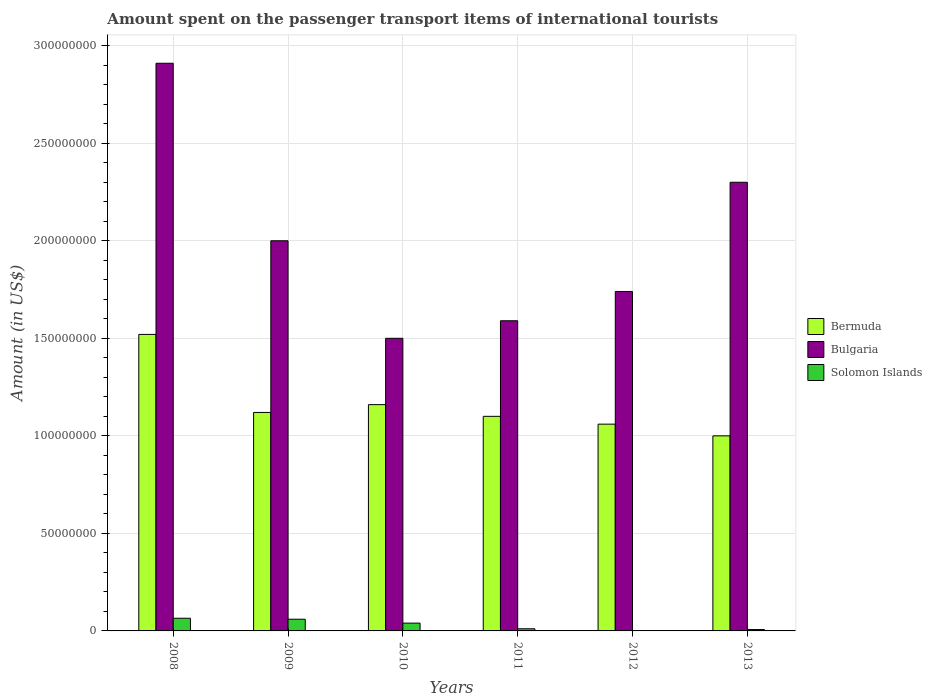How many groups of bars are there?
Your response must be concise. 6. Are the number of bars per tick equal to the number of legend labels?
Your answer should be compact. Yes. How many bars are there on the 2nd tick from the left?
Your answer should be very brief. 3. What is the label of the 5th group of bars from the left?
Give a very brief answer. 2012. In how many cases, is the number of bars for a given year not equal to the number of legend labels?
Offer a terse response. 0. What is the amount spent on the passenger transport items of international tourists in Bulgaria in 2008?
Offer a terse response. 2.91e+08. Across all years, what is the maximum amount spent on the passenger transport items of international tourists in Bermuda?
Provide a short and direct response. 1.52e+08. Across all years, what is the minimum amount spent on the passenger transport items of international tourists in Solomon Islands?
Your answer should be compact. 2.00e+05. What is the total amount spent on the passenger transport items of international tourists in Bulgaria in the graph?
Make the answer very short. 1.20e+09. What is the difference between the amount spent on the passenger transport items of international tourists in Solomon Islands in 2011 and the amount spent on the passenger transport items of international tourists in Bulgaria in 2009?
Offer a very short reply. -1.99e+08. What is the average amount spent on the passenger transport items of international tourists in Solomon Islands per year?
Provide a short and direct response. 3.08e+06. In the year 2013, what is the difference between the amount spent on the passenger transport items of international tourists in Bermuda and amount spent on the passenger transport items of international tourists in Bulgaria?
Make the answer very short. -1.30e+08. What is the ratio of the amount spent on the passenger transport items of international tourists in Bermuda in 2008 to that in 2011?
Give a very brief answer. 1.38. Is the amount spent on the passenger transport items of international tourists in Bermuda in 2011 less than that in 2012?
Your answer should be very brief. No. What is the difference between the highest and the second highest amount spent on the passenger transport items of international tourists in Bulgaria?
Offer a terse response. 6.10e+07. What is the difference between the highest and the lowest amount spent on the passenger transport items of international tourists in Bermuda?
Your response must be concise. 5.20e+07. What does the 3rd bar from the right in 2008 represents?
Provide a short and direct response. Bermuda. Is it the case that in every year, the sum of the amount spent on the passenger transport items of international tourists in Solomon Islands and amount spent on the passenger transport items of international tourists in Bulgaria is greater than the amount spent on the passenger transport items of international tourists in Bermuda?
Your answer should be very brief. Yes. Are all the bars in the graph horizontal?
Make the answer very short. No. How many years are there in the graph?
Provide a short and direct response. 6. What is the difference between two consecutive major ticks on the Y-axis?
Offer a very short reply. 5.00e+07. Does the graph contain any zero values?
Your answer should be compact. No. Where does the legend appear in the graph?
Provide a succinct answer. Center right. What is the title of the graph?
Provide a succinct answer. Amount spent on the passenger transport items of international tourists. What is the label or title of the Y-axis?
Provide a short and direct response. Amount (in US$). What is the Amount (in US$) of Bermuda in 2008?
Give a very brief answer. 1.52e+08. What is the Amount (in US$) in Bulgaria in 2008?
Keep it short and to the point. 2.91e+08. What is the Amount (in US$) of Solomon Islands in 2008?
Provide a short and direct response. 6.50e+06. What is the Amount (in US$) in Bermuda in 2009?
Offer a very short reply. 1.12e+08. What is the Amount (in US$) of Solomon Islands in 2009?
Your answer should be compact. 6.00e+06. What is the Amount (in US$) in Bermuda in 2010?
Keep it short and to the point. 1.16e+08. What is the Amount (in US$) of Bulgaria in 2010?
Your answer should be very brief. 1.50e+08. What is the Amount (in US$) in Solomon Islands in 2010?
Your answer should be very brief. 4.00e+06. What is the Amount (in US$) in Bermuda in 2011?
Offer a very short reply. 1.10e+08. What is the Amount (in US$) in Bulgaria in 2011?
Give a very brief answer. 1.59e+08. What is the Amount (in US$) of Solomon Islands in 2011?
Provide a succinct answer. 1.10e+06. What is the Amount (in US$) in Bermuda in 2012?
Keep it short and to the point. 1.06e+08. What is the Amount (in US$) of Bulgaria in 2012?
Offer a very short reply. 1.74e+08. What is the Amount (in US$) in Bermuda in 2013?
Make the answer very short. 1.00e+08. What is the Amount (in US$) in Bulgaria in 2013?
Provide a short and direct response. 2.30e+08. Across all years, what is the maximum Amount (in US$) in Bermuda?
Provide a succinct answer. 1.52e+08. Across all years, what is the maximum Amount (in US$) in Bulgaria?
Ensure brevity in your answer.  2.91e+08. Across all years, what is the maximum Amount (in US$) of Solomon Islands?
Provide a short and direct response. 6.50e+06. Across all years, what is the minimum Amount (in US$) in Bermuda?
Your response must be concise. 1.00e+08. Across all years, what is the minimum Amount (in US$) in Bulgaria?
Your answer should be compact. 1.50e+08. What is the total Amount (in US$) of Bermuda in the graph?
Ensure brevity in your answer.  6.96e+08. What is the total Amount (in US$) of Bulgaria in the graph?
Provide a succinct answer. 1.20e+09. What is the total Amount (in US$) of Solomon Islands in the graph?
Ensure brevity in your answer.  1.85e+07. What is the difference between the Amount (in US$) in Bermuda in 2008 and that in 2009?
Ensure brevity in your answer.  4.00e+07. What is the difference between the Amount (in US$) in Bulgaria in 2008 and that in 2009?
Give a very brief answer. 9.10e+07. What is the difference between the Amount (in US$) of Solomon Islands in 2008 and that in 2009?
Make the answer very short. 5.00e+05. What is the difference between the Amount (in US$) of Bermuda in 2008 and that in 2010?
Keep it short and to the point. 3.60e+07. What is the difference between the Amount (in US$) of Bulgaria in 2008 and that in 2010?
Offer a terse response. 1.41e+08. What is the difference between the Amount (in US$) in Solomon Islands in 2008 and that in 2010?
Offer a terse response. 2.50e+06. What is the difference between the Amount (in US$) of Bermuda in 2008 and that in 2011?
Your answer should be compact. 4.20e+07. What is the difference between the Amount (in US$) in Bulgaria in 2008 and that in 2011?
Offer a terse response. 1.32e+08. What is the difference between the Amount (in US$) of Solomon Islands in 2008 and that in 2011?
Offer a terse response. 5.40e+06. What is the difference between the Amount (in US$) of Bermuda in 2008 and that in 2012?
Your response must be concise. 4.60e+07. What is the difference between the Amount (in US$) in Bulgaria in 2008 and that in 2012?
Provide a succinct answer. 1.17e+08. What is the difference between the Amount (in US$) in Solomon Islands in 2008 and that in 2012?
Offer a terse response. 6.30e+06. What is the difference between the Amount (in US$) of Bermuda in 2008 and that in 2013?
Give a very brief answer. 5.20e+07. What is the difference between the Amount (in US$) of Bulgaria in 2008 and that in 2013?
Make the answer very short. 6.10e+07. What is the difference between the Amount (in US$) of Solomon Islands in 2008 and that in 2013?
Offer a very short reply. 5.80e+06. What is the difference between the Amount (in US$) of Bermuda in 2009 and that in 2010?
Offer a terse response. -4.00e+06. What is the difference between the Amount (in US$) in Solomon Islands in 2009 and that in 2010?
Make the answer very short. 2.00e+06. What is the difference between the Amount (in US$) in Bermuda in 2009 and that in 2011?
Offer a terse response. 2.00e+06. What is the difference between the Amount (in US$) in Bulgaria in 2009 and that in 2011?
Ensure brevity in your answer.  4.10e+07. What is the difference between the Amount (in US$) in Solomon Islands in 2009 and that in 2011?
Offer a terse response. 4.90e+06. What is the difference between the Amount (in US$) in Bermuda in 2009 and that in 2012?
Offer a very short reply. 6.00e+06. What is the difference between the Amount (in US$) of Bulgaria in 2009 and that in 2012?
Your answer should be very brief. 2.60e+07. What is the difference between the Amount (in US$) of Solomon Islands in 2009 and that in 2012?
Offer a very short reply. 5.80e+06. What is the difference between the Amount (in US$) of Bermuda in 2009 and that in 2013?
Keep it short and to the point. 1.20e+07. What is the difference between the Amount (in US$) in Bulgaria in 2009 and that in 2013?
Keep it short and to the point. -3.00e+07. What is the difference between the Amount (in US$) in Solomon Islands in 2009 and that in 2013?
Offer a very short reply. 5.30e+06. What is the difference between the Amount (in US$) of Bulgaria in 2010 and that in 2011?
Ensure brevity in your answer.  -9.00e+06. What is the difference between the Amount (in US$) of Solomon Islands in 2010 and that in 2011?
Your response must be concise. 2.90e+06. What is the difference between the Amount (in US$) in Bulgaria in 2010 and that in 2012?
Offer a very short reply. -2.40e+07. What is the difference between the Amount (in US$) in Solomon Islands in 2010 and that in 2012?
Provide a short and direct response. 3.80e+06. What is the difference between the Amount (in US$) of Bermuda in 2010 and that in 2013?
Keep it short and to the point. 1.60e+07. What is the difference between the Amount (in US$) of Bulgaria in 2010 and that in 2013?
Give a very brief answer. -8.00e+07. What is the difference between the Amount (in US$) in Solomon Islands in 2010 and that in 2013?
Your answer should be very brief. 3.30e+06. What is the difference between the Amount (in US$) in Bermuda in 2011 and that in 2012?
Keep it short and to the point. 4.00e+06. What is the difference between the Amount (in US$) of Bulgaria in 2011 and that in 2012?
Your answer should be very brief. -1.50e+07. What is the difference between the Amount (in US$) of Solomon Islands in 2011 and that in 2012?
Give a very brief answer. 9.00e+05. What is the difference between the Amount (in US$) in Bulgaria in 2011 and that in 2013?
Provide a succinct answer. -7.10e+07. What is the difference between the Amount (in US$) in Solomon Islands in 2011 and that in 2013?
Your response must be concise. 4.00e+05. What is the difference between the Amount (in US$) in Bulgaria in 2012 and that in 2013?
Provide a short and direct response. -5.60e+07. What is the difference between the Amount (in US$) in Solomon Islands in 2012 and that in 2013?
Provide a succinct answer. -5.00e+05. What is the difference between the Amount (in US$) of Bermuda in 2008 and the Amount (in US$) of Bulgaria in 2009?
Provide a short and direct response. -4.80e+07. What is the difference between the Amount (in US$) of Bermuda in 2008 and the Amount (in US$) of Solomon Islands in 2009?
Your answer should be very brief. 1.46e+08. What is the difference between the Amount (in US$) in Bulgaria in 2008 and the Amount (in US$) in Solomon Islands in 2009?
Provide a short and direct response. 2.85e+08. What is the difference between the Amount (in US$) of Bermuda in 2008 and the Amount (in US$) of Solomon Islands in 2010?
Your response must be concise. 1.48e+08. What is the difference between the Amount (in US$) of Bulgaria in 2008 and the Amount (in US$) of Solomon Islands in 2010?
Provide a succinct answer. 2.87e+08. What is the difference between the Amount (in US$) in Bermuda in 2008 and the Amount (in US$) in Bulgaria in 2011?
Your response must be concise. -7.00e+06. What is the difference between the Amount (in US$) in Bermuda in 2008 and the Amount (in US$) in Solomon Islands in 2011?
Give a very brief answer. 1.51e+08. What is the difference between the Amount (in US$) in Bulgaria in 2008 and the Amount (in US$) in Solomon Islands in 2011?
Provide a short and direct response. 2.90e+08. What is the difference between the Amount (in US$) in Bermuda in 2008 and the Amount (in US$) in Bulgaria in 2012?
Ensure brevity in your answer.  -2.20e+07. What is the difference between the Amount (in US$) of Bermuda in 2008 and the Amount (in US$) of Solomon Islands in 2012?
Make the answer very short. 1.52e+08. What is the difference between the Amount (in US$) of Bulgaria in 2008 and the Amount (in US$) of Solomon Islands in 2012?
Your answer should be very brief. 2.91e+08. What is the difference between the Amount (in US$) of Bermuda in 2008 and the Amount (in US$) of Bulgaria in 2013?
Provide a succinct answer. -7.80e+07. What is the difference between the Amount (in US$) of Bermuda in 2008 and the Amount (in US$) of Solomon Islands in 2013?
Your response must be concise. 1.51e+08. What is the difference between the Amount (in US$) of Bulgaria in 2008 and the Amount (in US$) of Solomon Islands in 2013?
Provide a succinct answer. 2.90e+08. What is the difference between the Amount (in US$) in Bermuda in 2009 and the Amount (in US$) in Bulgaria in 2010?
Offer a very short reply. -3.80e+07. What is the difference between the Amount (in US$) of Bermuda in 2009 and the Amount (in US$) of Solomon Islands in 2010?
Offer a very short reply. 1.08e+08. What is the difference between the Amount (in US$) in Bulgaria in 2009 and the Amount (in US$) in Solomon Islands in 2010?
Offer a very short reply. 1.96e+08. What is the difference between the Amount (in US$) of Bermuda in 2009 and the Amount (in US$) of Bulgaria in 2011?
Give a very brief answer. -4.70e+07. What is the difference between the Amount (in US$) of Bermuda in 2009 and the Amount (in US$) of Solomon Islands in 2011?
Keep it short and to the point. 1.11e+08. What is the difference between the Amount (in US$) in Bulgaria in 2009 and the Amount (in US$) in Solomon Islands in 2011?
Offer a terse response. 1.99e+08. What is the difference between the Amount (in US$) of Bermuda in 2009 and the Amount (in US$) of Bulgaria in 2012?
Your answer should be compact. -6.20e+07. What is the difference between the Amount (in US$) of Bermuda in 2009 and the Amount (in US$) of Solomon Islands in 2012?
Provide a succinct answer. 1.12e+08. What is the difference between the Amount (in US$) in Bulgaria in 2009 and the Amount (in US$) in Solomon Islands in 2012?
Your answer should be very brief. 2.00e+08. What is the difference between the Amount (in US$) in Bermuda in 2009 and the Amount (in US$) in Bulgaria in 2013?
Provide a succinct answer. -1.18e+08. What is the difference between the Amount (in US$) in Bermuda in 2009 and the Amount (in US$) in Solomon Islands in 2013?
Your answer should be very brief. 1.11e+08. What is the difference between the Amount (in US$) in Bulgaria in 2009 and the Amount (in US$) in Solomon Islands in 2013?
Your answer should be compact. 1.99e+08. What is the difference between the Amount (in US$) in Bermuda in 2010 and the Amount (in US$) in Bulgaria in 2011?
Ensure brevity in your answer.  -4.30e+07. What is the difference between the Amount (in US$) in Bermuda in 2010 and the Amount (in US$) in Solomon Islands in 2011?
Keep it short and to the point. 1.15e+08. What is the difference between the Amount (in US$) of Bulgaria in 2010 and the Amount (in US$) of Solomon Islands in 2011?
Offer a terse response. 1.49e+08. What is the difference between the Amount (in US$) of Bermuda in 2010 and the Amount (in US$) of Bulgaria in 2012?
Provide a succinct answer. -5.80e+07. What is the difference between the Amount (in US$) in Bermuda in 2010 and the Amount (in US$) in Solomon Islands in 2012?
Give a very brief answer. 1.16e+08. What is the difference between the Amount (in US$) of Bulgaria in 2010 and the Amount (in US$) of Solomon Islands in 2012?
Offer a very short reply. 1.50e+08. What is the difference between the Amount (in US$) in Bermuda in 2010 and the Amount (in US$) in Bulgaria in 2013?
Keep it short and to the point. -1.14e+08. What is the difference between the Amount (in US$) in Bermuda in 2010 and the Amount (in US$) in Solomon Islands in 2013?
Offer a very short reply. 1.15e+08. What is the difference between the Amount (in US$) of Bulgaria in 2010 and the Amount (in US$) of Solomon Islands in 2013?
Provide a short and direct response. 1.49e+08. What is the difference between the Amount (in US$) of Bermuda in 2011 and the Amount (in US$) of Bulgaria in 2012?
Your answer should be compact. -6.40e+07. What is the difference between the Amount (in US$) of Bermuda in 2011 and the Amount (in US$) of Solomon Islands in 2012?
Provide a short and direct response. 1.10e+08. What is the difference between the Amount (in US$) in Bulgaria in 2011 and the Amount (in US$) in Solomon Islands in 2012?
Your answer should be compact. 1.59e+08. What is the difference between the Amount (in US$) of Bermuda in 2011 and the Amount (in US$) of Bulgaria in 2013?
Make the answer very short. -1.20e+08. What is the difference between the Amount (in US$) in Bermuda in 2011 and the Amount (in US$) in Solomon Islands in 2013?
Give a very brief answer. 1.09e+08. What is the difference between the Amount (in US$) in Bulgaria in 2011 and the Amount (in US$) in Solomon Islands in 2013?
Your answer should be very brief. 1.58e+08. What is the difference between the Amount (in US$) of Bermuda in 2012 and the Amount (in US$) of Bulgaria in 2013?
Provide a succinct answer. -1.24e+08. What is the difference between the Amount (in US$) of Bermuda in 2012 and the Amount (in US$) of Solomon Islands in 2013?
Your response must be concise. 1.05e+08. What is the difference between the Amount (in US$) of Bulgaria in 2012 and the Amount (in US$) of Solomon Islands in 2013?
Keep it short and to the point. 1.73e+08. What is the average Amount (in US$) of Bermuda per year?
Give a very brief answer. 1.16e+08. What is the average Amount (in US$) of Bulgaria per year?
Make the answer very short. 2.01e+08. What is the average Amount (in US$) of Solomon Islands per year?
Provide a short and direct response. 3.08e+06. In the year 2008, what is the difference between the Amount (in US$) of Bermuda and Amount (in US$) of Bulgaria?
Your answer should be very brief. -1.39e+08. In the year 2008, what is the difference between the Amount (in US$) of Bermuda and Amount (in US$) of Solomon Islands?
Ensure brevity in your answer.  1.46e+08. In the year 2008, what is the difference between the Amount (in US$) in Bulgaria and Amount (in US$) in Solomon Islands?
Your response must be concise. 2.84e+08. In the year 2009, what is the difference between the Amount (in US$) in Bermuda and Amount (in US$) in Bulgaria?
Ensure brevity in your answer.  -8.80e+07. In the year 2009, what is the difference between the Amount (in US$) in Bermuda and Amount (in US$) in Solomon Islands?
Ensure brevity in your answer.  1.06e+08. In the year 2009, what is the difference between the Amount (in US$) in Bulgaria and Amount (in US$) in Solomon Islands?
Provide a short and direct response. 1.94e+08. In the year 2010, what is the difference between the Amount (in US$) of Bermuda and Amount (in US$) of Bulgaria?
Make the answer very short. -3.40e+07. In the year 2010, what is the difference between the Amount (in US$) in Bermuda and Amount (in US$) in Solomon Islands?
Make the answer very short. 1.12e+08. In the year 2010, what is the difference between the Amount (in US$) of Bulgaria and Amount (in US$) of Solomon Islands?
Provide a short and direct response. 1.46e+08. In the year 2011, what is the difference between the Amount (in US$) of Bermuda and Amount (in US$) of Bulgaria?
Your answer should be very brief. -4.90e+07. In the year 2011, what is the difference between the Amount (in US$) in Bermuda and Amount (in US$) in Solomon Islands?
Provide a succinct answer. 1.09e+08. In the year 2011, what is the difference between the Amount (in US$) of Bulgaria and Amount (in US$) of Solomon Islands?
Your answer should be compact. 1.58e+08. In the year 2012, what is the difference between the Amount (in US$) of Bermuda and Amount (in US$) of Bulgaria?
Give a very brief answer. -6.80e+07. In the year 2012, what is the difference between the Amount (in US$) of Bermuda and Amount (in US$) of Solomon Islands?
Your response must be concise. 1.06e+08. In the year 2012, what is the difference between the Amount (in US$) of Bulgaria and Amount (in US$) of Solomon Islands?
Ensure brevity in your answer.  1.74e+08. In the year 2013, what is the difference between the Amount (in US$) of Bermuda and Amount (in US$) of Bulgaria?
Ensure brevity in your answer.  -1.30e+08. In the year 2013, what is the difference between the Amount (in US$) of Bermuda and Amount (in US$) of Solomon Islands?
Offer a very short reply. 9.93e+07. In the year 2013, what is the difference between the Amount (in US$) of Bulgaria and Amount (in US$) of Solomon Islands?
Offer a terse response. 2.29e+08. What is the ratio of the Amount (in US$) in Bermuda in 2008 to that in 2009?
Make the answer very short. 1.36. What is the ratio of the Amount (in US$) in Bulgaria in 2008 to that in 2009?
Ensure brevity in your answer.  1.46. What is the ratio of the Amount (in US$) in Bermuda in 2008 to that in 2010?
Make the answer very short. 1.31. What is the ratio of the Amount (in US$) of Bulgaria in 2008 to that in 2010?
Provide a succinct answer. 1.94. What is the ratio of the Amount (in US$) in Solomon Islands in 2008 to that in 2010?
Your answer should be compact. 1.62. What is the ratio of the Amount (in US$) in Bermuda in 2008 to that in 2011?
Offer a very short reply. 1.38. What is the ratio of the Amount (in US$) of Bulgaria in 2008 to that in 2011?
Keep it short and to the point. 1.83. What is the ratio of the Amount (in US$) in Solomon Islands in 2008 to that in 2011?
Provide a short and direct response. 5.91. What is the ratio of the Amount (in US$) in Bermuda in 2008 to that in 2012?
Ensure brevity in your answer.  1.43. What is the ratio of the Amount (in US$) in Bulgaria in 2008 to that in 2012?
Your response must be concise. 1.67. What is the ratio of the Amount (in US$) in Solomon Islands in 2008 to that in 2012?
Keep it short and to the point. 32.5. What is the ratio of the Amount (in US$) of Bermuda in 2008 to that in 2013?
Ensure brevity in your answer.  1.52. What is the ratio of the Amount (in US$) in Bulgaria in 2008 to that in 2013?
Ensure brevity in your answer.  1.27. What is the ratio of the Amount (in US$) of Solomon Islands in 2008 to that in 2013?
Your answer should be very brief. 9.29. What is the ratio of the Amount (in US$) of Bermuda in 2009 to that in 2010?
Ensure brevity in your answer.  0.97. What is the ratio of the Amount (in US$) in Bulgaria in 2009 to that in 2010?
Keep it short and to the point. 1.33. What is the ratio of the Amount (in US$) of Solomon Islands in 2009 to that in 2010?
Your answer should be compact. 1.5. What is the ratio of the Amount (in US$) of Bermuda in 2009 to that in 2011?
Your response must be concise. 1.02. What is the ratio of the Amount (in US$) of Bulgaria in 2009 to that in 2011?
Your answer should be compact. 1.26. What is the ratio of the Amount (in US$) in Solomon Islands in 2009 to that in 2011?
Your response must be concise. 5.45. What is the ratio of the Amount (in US$) in Bermuda in 2009 to that in 2012?
Your response must be concise. 1.06. What is the ratio of the Amount (in US$) in Bulgaria in 2009 to that in 2012?
Make the answer very short. 1.15. What is the ratio of the Amount (in US$) of Bermuda in 2009 to that in 2013?
Keep it short and to the point. 1.12. What is the ratio of the Amount (in US$) of Bulgaria in 2009 to that in 2013?
Your answer should be compact. 0.87. What is the ratio of the Amount (in US$) of Solomon Islands in 2009 to that in 2013?
Provide a short and direct response. 8.57. What is the ratio of the Amount (in US$) of Bermuda in 2010 to that in 2011?
Offer a very short reply. 1.05. What is the ratio of the Amount (in US$) in Bulgaria in 2010 to that in 2011?
Your answer should be compact. 0.94. What is the ratio of the Amount (in US$) in Solomon Islands in 2010 to that in 2011?
Make the answer very short. 3.64. What is the ratio of the Amount (in US$) in Bermuda in 2010 to that in 2012?
Keep it short and to the point. 1.09. What is the ratio of the Amount (in US$) in Bulgaria in 2010 to that in 2012?
Offer a terse response. 0.86. What is the ratio of the Amount (in US$) in Solomon Islands in 2010 to that in 2012?
Provide a short and direct response. 20. What is the ratio of the Amount (in US$) of Bermuda in 2010 to that in 2013?
Your response must be concise. 1.16. What is the ratio of the Amount (in US$) in Bulgaria in 2010 to that in 2013?
Your answer should be very brief. 0.65. What is the ratio of the Amount (in US$) of Solomon Islands in 2010 to that in 2013?
Your answer should be very brief. 5.71. What is the ratio of the Amount (in US$) in Bermuda in 2011 to that in 2012?
Offer a terse response. 1.04. What is the ratio of the Amount (in US$) of Bulgaria in 2011 to that in 2012?
Your response must be concise. 0.91. What is the ratio of the Amount (in US$) in Solomon Islands in 2011 to that in 2012?
Ensure brevity in your answer.  5.5. What is the ratio of the Amount (in US$) of Bulgaria in 2011 to that in 2013?
Your answer should be compact. 0.69. What is the ratio of the Amount (in US$) of Solomon Islands in 2011 to that in 2013?
Make the answer very short. 1.57. What is the ratio of the Amount (in US$) of Bermuda in 2012 to that in 2013?
Give a very brief answer. 1.06. What is the ratio of the Amount (in US$) of Bulgaria in 2012 to that in 2013?
Make the answer very short. 0.76. What is the ratio of the Amount (in US$) of Solomon Islands in 2012 to that in 2013?
Make the answer very short. 0.29. What is the difference between the highest and the second highest Amount (in US$) in Bermuda?
Keep it short and to the point. 3.60e+07. What is the difference between the highest and the second highest Amount (in US$) in Bulgaria?
Provide a short and direct response. 6.10e+07. What is the difference between the highest and the second highest Amount (in US$) in Solomon Islands?
Your answer should be compact. 5.00e+05. What is the difference between the highest and the lowest Amount (in US$) in Bermuda?
Your answer should be very brief. 5.20e+07. What is the difference between the highest and the lowest Amount (in US$) of Bulgaria?
Your answer should be very brief. 1.41e+08. What is the difference between the highest and the lowest Amount (in US$) in Solomon Islands?
Provide a succinct answer. 6.30e+06. 